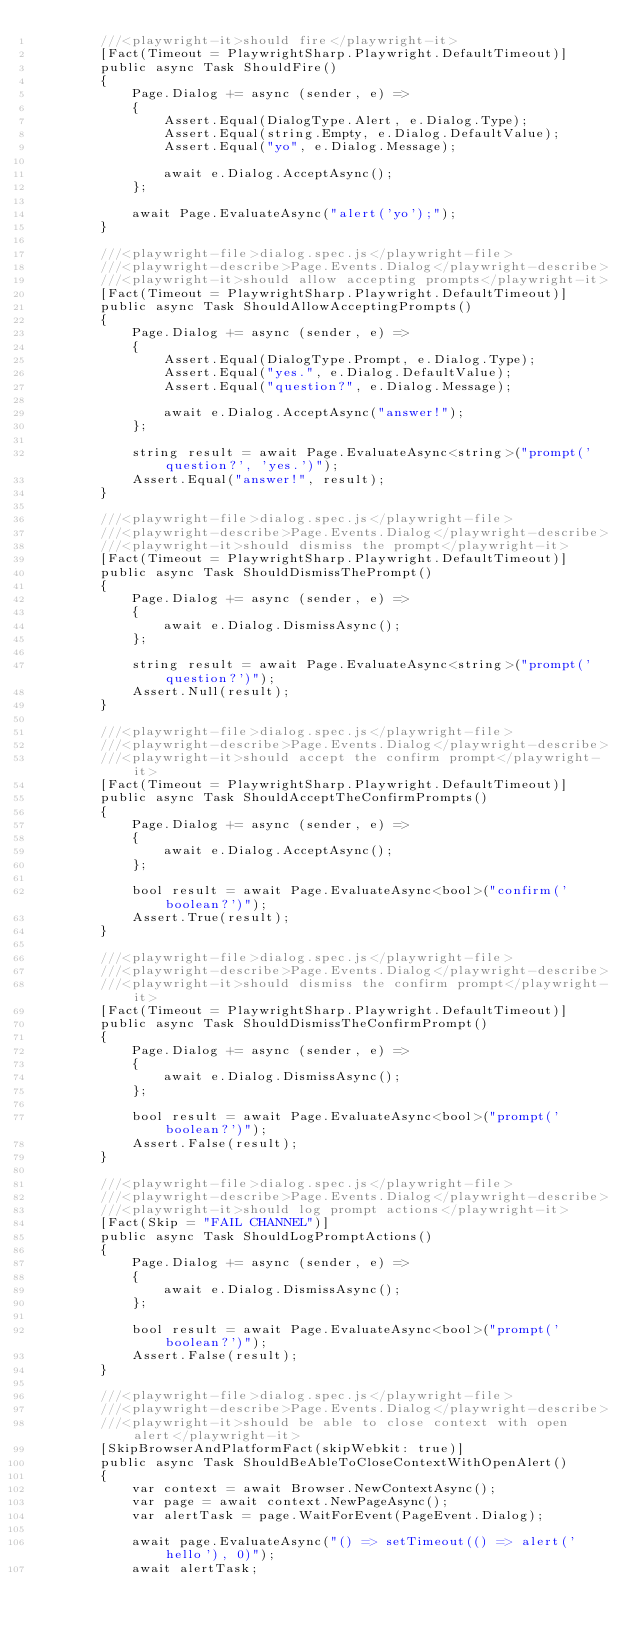Convert code to text. <code><loc_0><loc_0><loc_500><loc_500><_C#_>        ///<playwright-it>should fire</playwright-it>
        [Fact(Timeout = PlaywrightSharp.Playwright.DefaultTimeout)]
        public async Task ShouldFire()
        {
            Page.Dialog += async (sender, e) =>
            {
                Assert.Equal(DialogType.Alert, e.Dialog.Type);
                Assert.Equal(string.Empty, e.Dialog.DefaultValue);
                Assert.Equal("yo", e.Dialog.Message);

                await e.Dialog.AcceptAsync();
            };

            await Page.EvaluateAsync("alert('yo');");
        }

        ///<playwright-file>dialog.spec.js</playwright-file>
        ///<playwright-describe>Page.Events.Dialog</playwright-describe>
        ///<playwright-it>should allow accepting prompts</playwright-it>
        [Fact(Timeout = PlaywrightSharp.Playwright.DefaultTimeout)]
        public async Task ShouldAllowAcceptingPrompts()
        {
            Page.Dialog += async (sender, e) =>
            {
                Assert.Equal(DialogType.Prompt, e.Dialog.Type);
                Assert.Equal("yes.", e.Dialog.DefaultValue);
                Assert.Equal("question?", e.Dialog.Message);

                await e.Dialog.AcceptAsync("answer!");
            };

            string result = await Page.EvaluateAsync<string>("prompt('question?', 'yes.')");
            Assert.Equal("answer!", result);
        }

        ///<playwright-file>dialog.spec.js</playwright-file>
        ///<playwright-describe>Page.Events.Dialog</playwright-describe>
        ///<playwright-it>should dismiss the prompt</playwright-it>
        [Fact(Timeout = PlaywrightSharp.Playwright.DefaultTimeout)]
        public async Task ShouldDismissThePrompt()
        {
            Page.Dialog += async (sender, e) =>
            {
                await e.Dialog.DismissAsync();
            };

            string result = await Page.EvaluateAsync<string>("prompt('question?')");
            Assert.Null(result);
        }

        ///<playwright-file>dialog.spec.js</playwright-file>
        ///<playwright-describe>Page.Events.Dialog</playwright-describe>
        ///<playwright-it>should accept the confirm prompt</playwright-it>
        [Fact(Timeout = PlaywrightSharp.Playwright.DefaultTimeout)]
        public async Task ShouldAcceptTheConfirmPrompts()
        {
            Page.Dialog += async (sender, e) =>
            {
                await e.Dialog.AcceptAsync();
            };

            bool result = await Page.EvaluateAsync<bool>("confirm('boolean?')");
            Assert.True(result);
        }

        ///<playwright-file>dialog.spec.js</playwright-file>
        ///<playwright-describe>Page.Events.Dialog</playwright-describe>
        ///<playwright-it>should dismiss the confirm prompt</playwright-it>
        [Fact(Timeout = PlaywrightSharp.Playwright.DefaultTimeout)]
        public async Task ShouldDismissTheConfirmPrompt()
        {
            Page.Dialog += async (sender, e) =>
            {
                await e.Dialog.DismissAsync();
            };

            bool result = await Page.EvaluateAsync<bool>("prompt('boolean?')");
            Assert.False(result);
        }

        ///<playwright-file>dialog.spec.js</playwright-file>
        ///<playwright-describe>Page.Events.Dialog</playwright-describe>
        ///<playwright-it>should log prompt actions</playwright-it>
        [Fact(Skip = "FAIL CHANNEL")]
        public async Task ShouldLogPromptActions()
        {
            Page.Dialog += async (sender, e) =>
            {
                await e.Dialog.DismissAsync();
            };

            bool result = await Page.EvaluateAsync<bool>("prompt('boolean?')");
            Assert.False(result);
        }

        ///<playwright-file>dialog.spec.js</playwright-file>
        ///<playwright-describe>Page.Events.Dialog</playwright-describe>
        ///<playwright-it>should be able to close context with open alert</playwright-it>
        [SkipBrowserAndPlatformFact(skipWebkit: true)]
        public async Task ShouldBeAbleToCloseContextWithOpenAlert()
        {
            var context = await Browser.NewContextAsync();
            var page = await context.NewPageAsync();
            var alertTask = page.WaitForEvent(PageEvent.Dialog);

            await page.EvaluateAsync("() => setTimeout(() => alert('hello'), 0)");
            await alertTask;</code> 